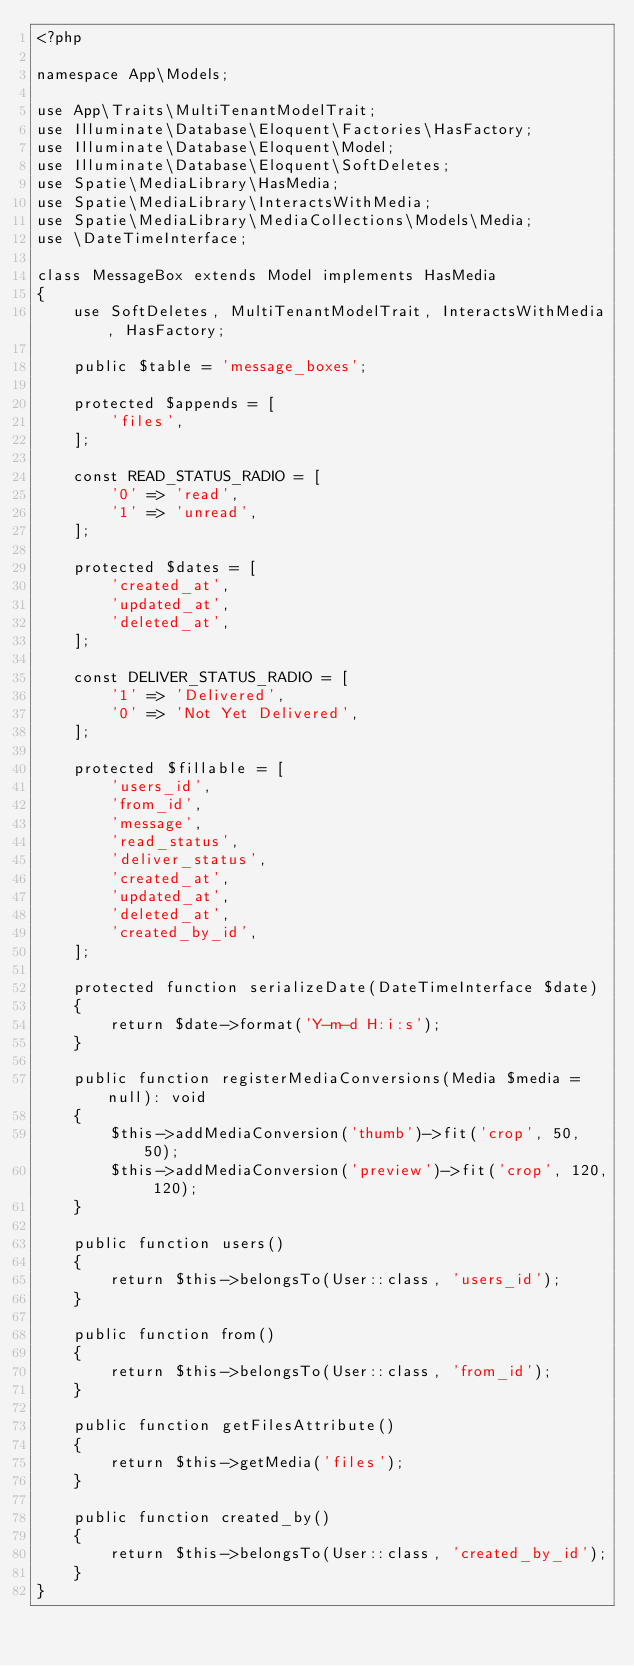Convert code to text. <code><loc_0><loc_0><loc_500><loc_500><_PHP_><?php

namespace App\Models;

use App\Traits\MultiTenantModelTrait;
use Illuminate\Database\Eloquent\Factories\HasFactory;
use Illuminate\Database\Eloquent\Model;
use Illuminate\Database\Eloquent\SoftDeletes;
use Spatie\MediaLibrary\HasMedia;
use Spatie\MediaLibrary\InteractsWithMedia;
use Spatie\MediaLibrary\MediaCollections\Models\Media;
use \DateTimeInterface;

class MessageBox extends Model implements HasMedia
{
    use SoftDeletes, MultiTenantModelTrait, InteractsWithMedia, HasFactory;

    public $table = 'message_boxes';

    protected $appends = [
        'files',
    ];

    const READ_STATUS_RADIO = [
        '0' => 'read',
        '1' => 'unread',
    ];

    protected $dates = [
        'created_at',
        'updated_at',
        'deleted_at',
    ];

    const DELIVER_STATUS_RADIO = [
        '1' => 'Delivered',
        '0' => 'Not Yet Delivered',
    ];

    protected $fillable = [
        'users_id',
        'from_id',
        'message',
        'read_status',
        'deliver_status',
        'created_at',
        'updated_at',
        'deleted_at',
        'created_by_id',
    ];

    protected function serializeDate(DateTimeInterface $date)
    {
        return $date->format('Y-m-d H:i:s');
    }

    public function registerMediaConversions(Media $media = null): void
    {
        $this->addMediaConversion('thumb')->fit('crop', 50, 50);
        $this->addMediaConversion('preview')->fit('crop', 120, 120);
    }

    public function users()
    {
        return $this->belongsTo(User::class, 'users_id');
    }

    public function from()
    {
        return $this->belongsTo(User::class, 'from_id');
    }

    public function getFilesAttribute()
    {
        return $this->getMedia('files');
    }

    public function created_by()
    {
        return $this->belongsTo(User::class, 'created_by_id');
    }
}
</code> 